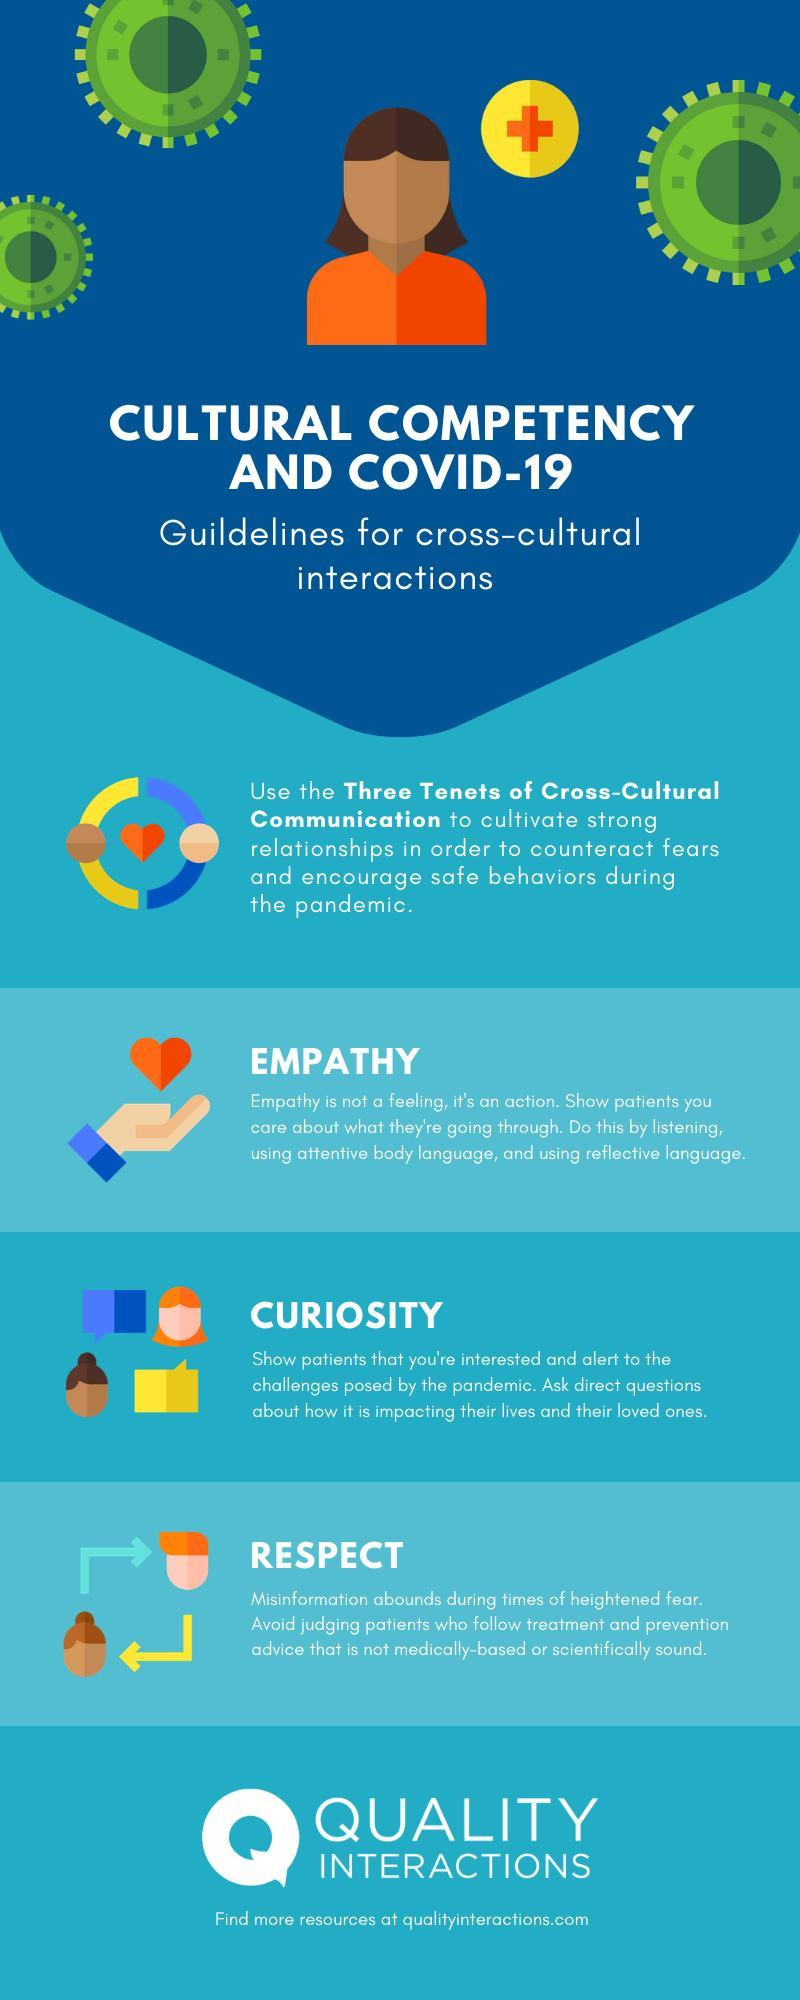What are the three tenets of cross-cultural communication?
Answer the question with a short phrase. EMPATHY, CURIOSITY, RESPECT 